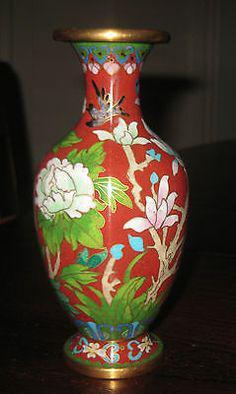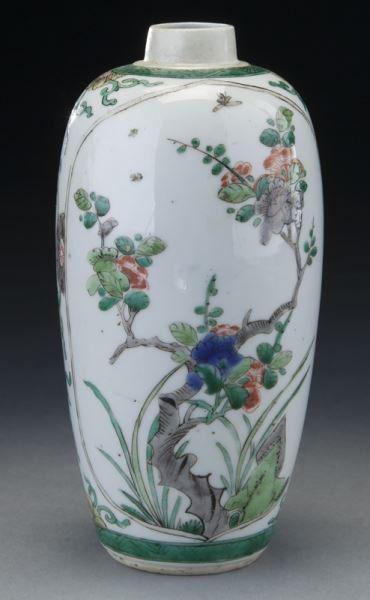The first image is the image on the left, the second image is the image on the right. Given the left and right images, does the statement "One ceramic vase features floral motifs and only blue and white colors, and the other vase has a narrow neck with a wider round bottom and includes pink flowers as decoration." hold true? Answer yes or no. No. The first image is the image on the left, the second image is the image on the right. Evaluate the accuracy of this statement regarding the images: "In at least one image there is a all blue and white vase with a circular middle.". Is it true? Answer yes or no. No. 